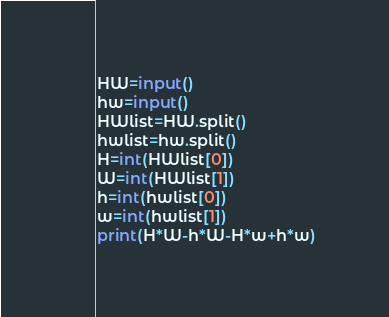Convert code to text. <code><loc_0><loc_0><loc_500><loc_500><_Python_>HW=input()
hw=input()
HWlist=HW.split()
hwlist=hw.split()
H=int(HWlist[0])
W=int(HWlist[1])
h=int(hwlist[0])
w=int(hwlist[1])
print(H*W-h*W-H*w+h*w)
</code> 